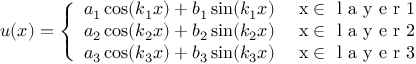Convert formula to latex. <formula><loc_0><loc_0><loc_500><loc_500>u ( x ) = \left \{ \begin{array} { l l } { a _ { 1 } \cos ( k _ { 1 } x ) + b _ { 1 } \sin ( k _ { 1 } x ) } & { x \in l a y e r 1 } \\ { a _ { 2 } \cos ( k _ { 2 } x ) + b _ { 2 } \sin ( k _ { 2 } x ) } & { x \in l a y e r 2 } \\ { a _ { 3 } \cos ( k _ { 3 } x ) + b _ { 3 } \sin ( k _ { 3 } x ) } & { x \in l a y e r 3 } \end{array}</formula> 